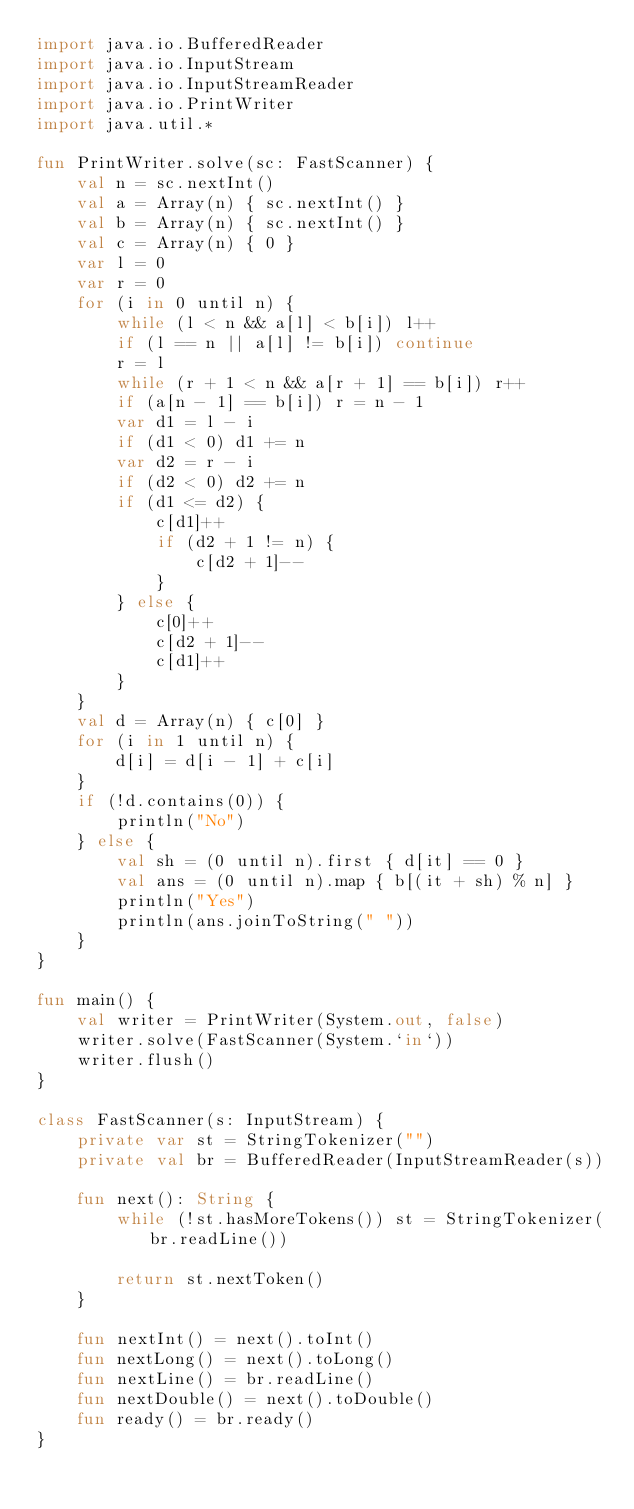Convert code to text. <code><loc_0><loc_0><loc_500><loc_500><_Kotlin_>import java.io.BufferedReader
import java.io.InputStream
import java.io.InputStreamReader
import java.io.PrintWriter
import java.util.*

fun PrintWriter.solve(sc: FastScanner) {
    val n = sc.nextInt()
    val a = Array(n) { sc.nextInt() }
    val b = Array(n) { sc.nextInt() }
    val c = Array(n) { 0 }
    var l = 0
    var r = 0
    for (i in 0 until n) {
        while (l < n && a[l] < b[i]) l++
        if (l == n || a[l] != b[i]) continue
        r = l
        while (r + 1 < n && a[r + 1] == b[i]) r++
        if (a[n - 1] == b[i]) r = n - 1
        var d1 = l - i
        if (d1 < 0) d1 += n
        var d2 = r - i
        if (d2 < 0) d2 += n
        if (d1 <= d2) {
            c[d1]++
            if (d2 + 1 != n) {
                c[d2 + 1]--
            }
        } else {
            c[0]++
            c[d2 + 1]--
            c[d1]++
        }
    }
    val d = Array(n) { c[0] }
    for (i in 1 until n) {
        d[i] = d[i - 1] + c[i]
    }
    if (!d.contains(0)) {
        println("No")
    } else {
        val sh = (0 until n).first { d[it] == 0 }
        val ans = (0 until n).map { b[(it + sh) % n] }
        println("Yes")
        println(ans.joinToString(" "))
    }
}

fun main() {
    val writer = PrintWriter(System.out, false)
    writer.solve(FastScanner(System.`in`))
    writer.flush()
}

class FastScanner(s: InputStream) {
    private var st = StringTokenizer("")
    private val br = BufferedReader(InputStreamReader(s))

    fun next(): String {
        while (!st.hasMoreTokens()) st = StringTokenizer(br.readLine())

        return st.nextToken()
    }

    fun nextInt() = next().toInt()
    fun nextLong() = next().toLong()
    fun nextLine() = br.readLine()
    fun nextDouble() = next().toDouble()
    fun ready() = br.ready()
}
</code> 